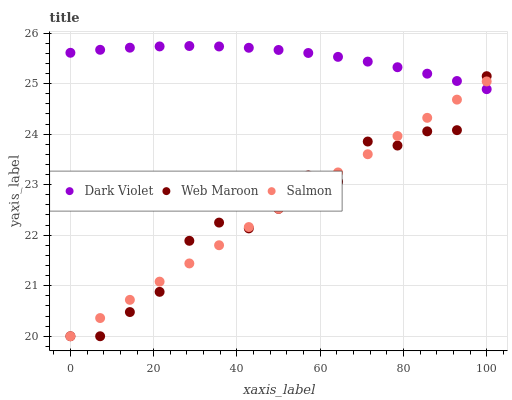Does Web Maroon have the minimum area under the curve?
Answer yes or no. Yes. Does Dark Violet have the maximum area under the curve?
Answer yes or no. Yes. Does Dark Violet have the minimum area under the curve?
Answer yes or no. No. Does Web Maroon have the maximum area under the curve?
Answer yes or no. No. Is Salmon the smoothest?
Answer yes or no. Yes. Is Web Maroon the roughest?
Answer yes or no. Yes. Is Dark Violet the smoothest?
Answer yes or no. No. Is Dark Violet the roughest?
Answer yes or no. No. Does Salmon have the lowest value?
Answer yes or no. Yes. Does Dark Violet have the lowest value?
Answer yes or no. No. Does Dark Violet have the highest value?
Answer yes or no. Yes. Does Web Maroon have the highest value?
Answer yes or no. No. Does Salmon intersect Dark Violet?
Answer yes or no. Yes. Is Salmon less than Dark Violet?
Answer yes or no. No. Is Salmon greater than Dark Violet?
Answer yes or no. No. 